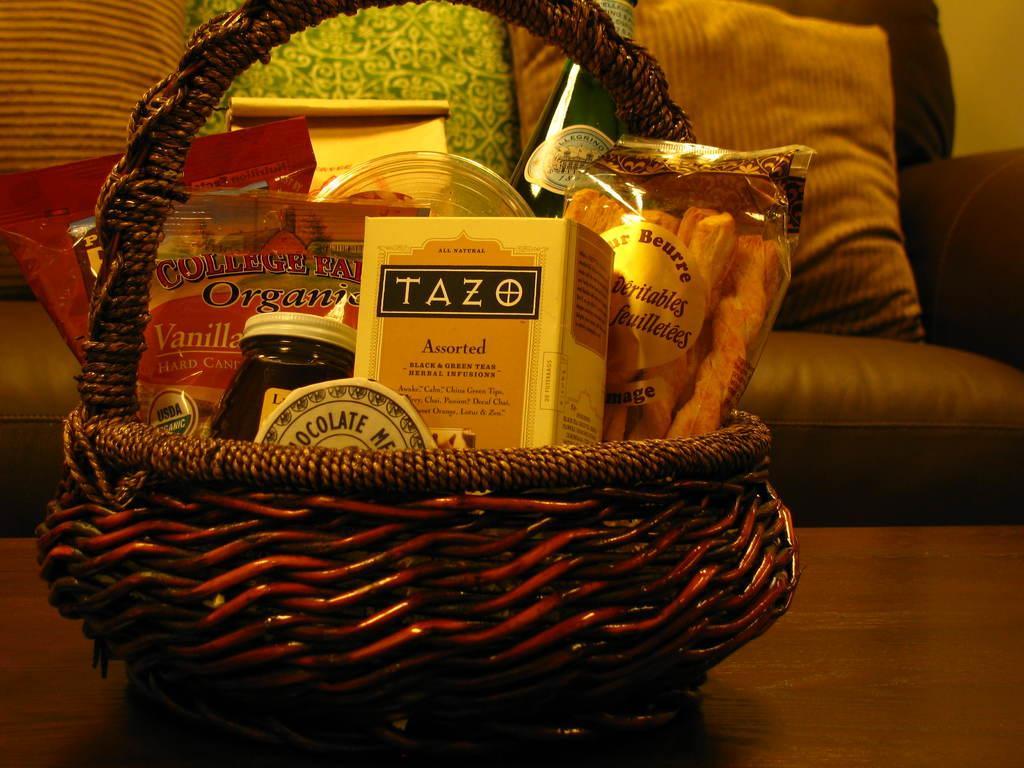Describe this image in one or two sentences. In this image we can see the basket on the table. In that basket we can see the box, bottles and packets with food items. And at the back we can see the couch and pillows on it. 